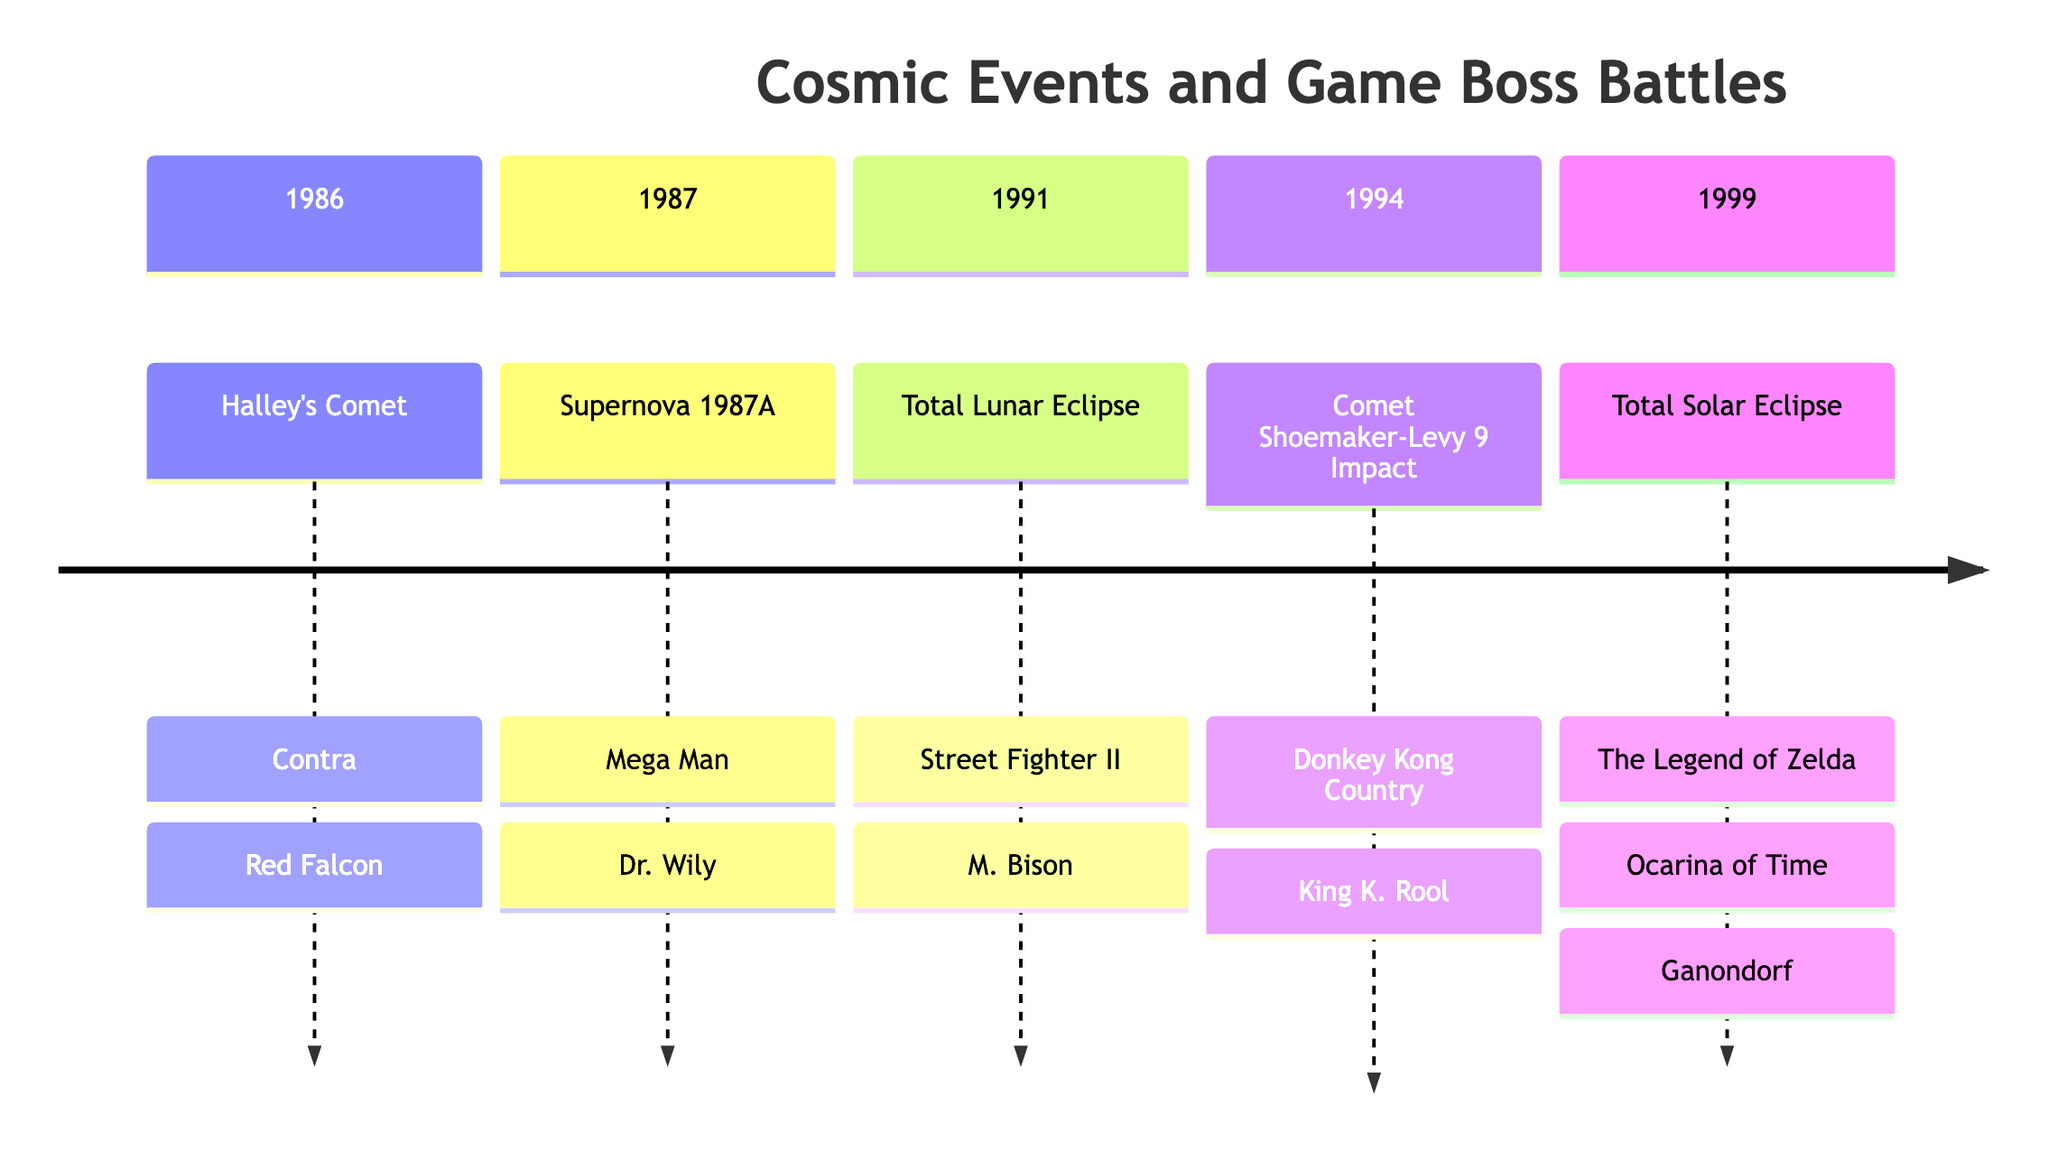What cosmic event corresponds to the year 1986? The diagram shows Halley's Comet associated with the year 1986. By locating the timeline section for 1986, we can see that it specifically mentions Halley's Comet as the cosmic event for that year.
Answer: Halley's Comet Which game boss is linked to the total solar eclipse in 1999? Referring to the 1999 section of the diagram, the total solar eclipse is associated with the boss Ganondorf from The Legend of Zelda: Ocarina of Time.
Answer: Ganondorf How many significant cosmic events are listed in the diagram? The diagram outlines a total of 5 cosmic events. We can count each unique event in each section to arrive at this number.
Answer: 5 What game is paired with the supernova event of 1987? In the section for 1987, the diagram shows Supernova 1987A is linked with the game Mega Man. This can be confirmed by checking the year and the corresponding game.
Answer: Mega Man Which boss battle occurs during the total lunar eclipse? The diagram indicates that the boss M. Bison from Street Fighter II is associated with the total lunar eclipse in 1991. We look at the 1991 section to find this information.
Answer: M. Bison In which year did the comet Shoemaker-Levy 9 impact occur? The diagram reveals that this event took place in the year 1994. By checking the timeline, we can confirm the corresponding year.
Answer: 1994 